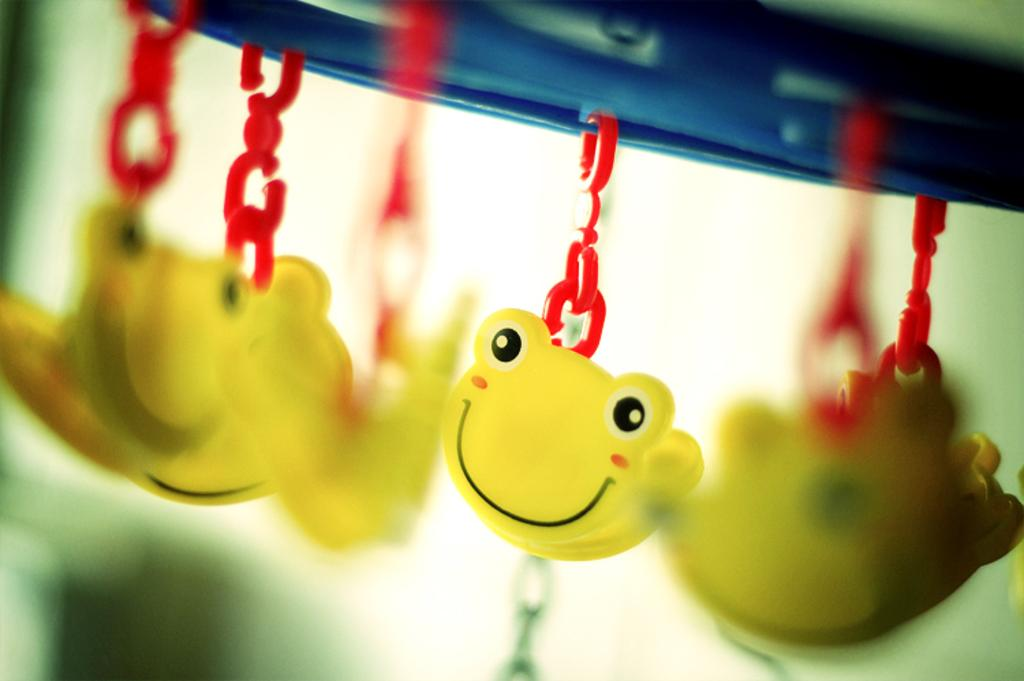What type of objects can be seen in the image? There are toys in the image. How have the toys been altered or changed? The toys appear to be transformed or changed into an object. Can you describe the background of the image? The background of the image is blurred. How many times has the can been folded in the image? There is no can present in the image, so it cannot be folded. 